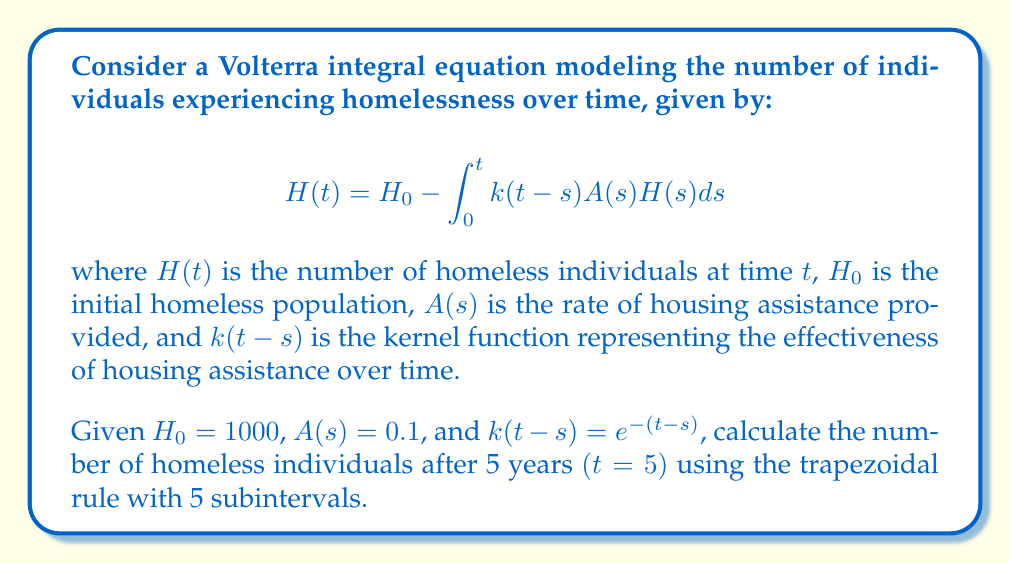Teach me how to tackle this problem. To solve this Volterra integral equation using the trapezoidal rule, we'll follow these steps:

1) First, we'll set up the trapezoidal rule for the integral:

   $$\int_0^t f(s)ds \approx \frac{\Delta t}{2}[f(0) + 2f(\Delta t) + 2f(2\Delta t) + ... + 2f((n-1)\Delta t) + f(n\Delta t)]$$

   where $\Delta t = t/n$, and $n$ is the number of subintervals.

2) In our case, $t = 5$ and $n = 5$, so $\Delta t = 1$.

3) We need to evaluate $f(s) = k(t-s)A(s)H(s)$ at $s = 0, 1, 2, 3, 4, 5$.

4) We'll use an iterative approach to calculate $H(s)$ at each point:

   $H(0) = H_0 = 1000$
   
   For $s = 1$ to $5$:
   $$H(s) = 1000 - \frac{1}{2}[f(0) + 2f(1) + 2f(2) + ... + 2f(s-1) + f(s)]$$

5) Let's calculate step by step:

   $H(0) = 1000$
   
   $H(1) = 1000 - \frac{1}{2}[0.1 \cdot 1000 \cdot e^{-1} + 0.1 \cdot H(1)] \approx 951.23$
   
   $H(2) = 1000 - \frac{1}{2}[0.1 \cdot 1000 \cdot e^{-2} + 2 \cdot 0.1 \cdot 951.23 \cdot e^{-1} + 0.1 \cdot H(2)] \approx 906.31$
   
   $H(3) = 1000 - \frac{1}{2}[0.1 \cdot 1000 \cdot e^{-3} + 2 \cdot 0.1 \cdot 951.23 \cdot e^{-2} + 2 \cdot 0.1 \cdot 906.31 \cdot e^{-1} + 0.1 \cdot H(3)] \approx 864.98$
   
   $H(4) = 1000 - \frac{1}{2}[0.1 \cdot 1000 \cdot e^{-4} + 2 \cdot 0.1 \cdot 951.23 \cdot e^{-3} + 2 \cdot 0.1 \cdot 906.31 \cdot e^{-2} + 2 \cdot 0.1 \cdot 864.98 \cdot e^{-1} + 0.1 \cdot H(4)] \approx 826.99$
   
   $H(5) = 1000 - \frac{1}{2}[0.1 \cdot 1000 \cdot e^{-5} + 2 \cdot 0.1 \cdot 951.23 \cdot e^{-4} + 2 \cdot 0.1 \cdot 906.31 \cdot e^{-3} + 2 \cdot 0.1 \cdot 864.98 \cdot e^{-2} + 2 \cdot 0.1 \cdot 826.99 \cdot e^{-1} + 0.1 \cdot H(5)] \approx 792.11$

6) Therefore, the number of homeless individuals after 5 years is approximately 792.11.
Answer: 792.11 